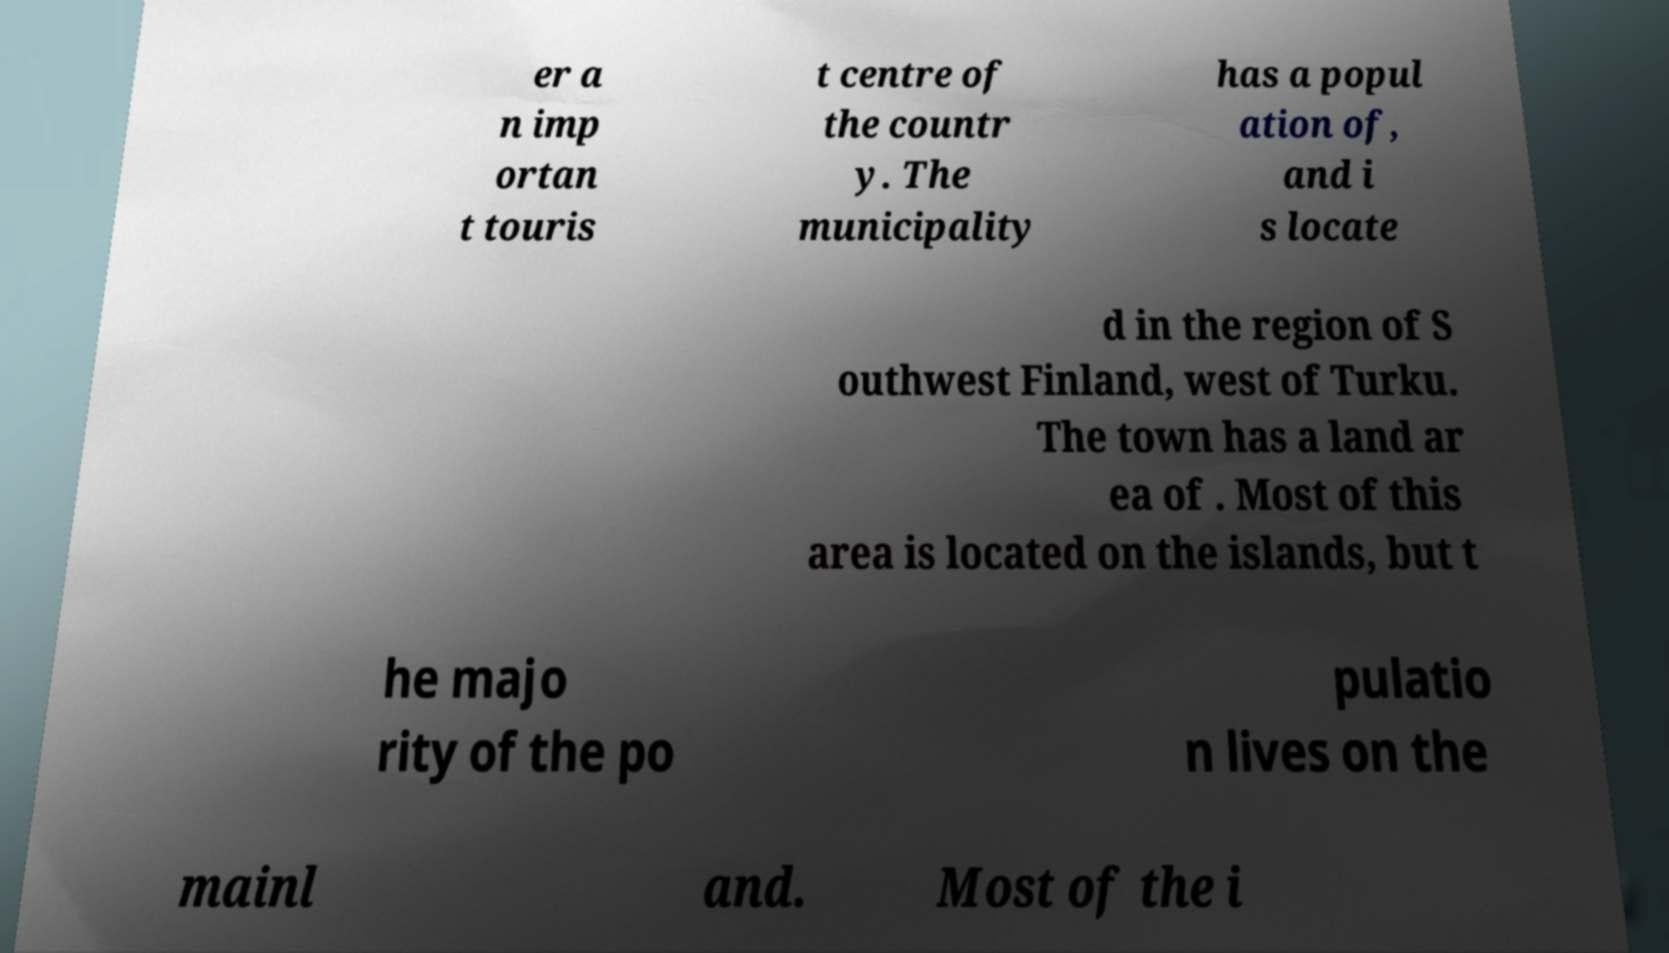Could you extract and type out the text from this image? er a n imp ortan t touris t centre of the countr y. The municipality has a popul ation of, and i s locate d in the region of S outhwest Finland, west of Turku. The town has a land ar ea of . Most of this area is located on the islands, but t he majo rity of the po pulatio n lives on the mainl and. Most of the i 